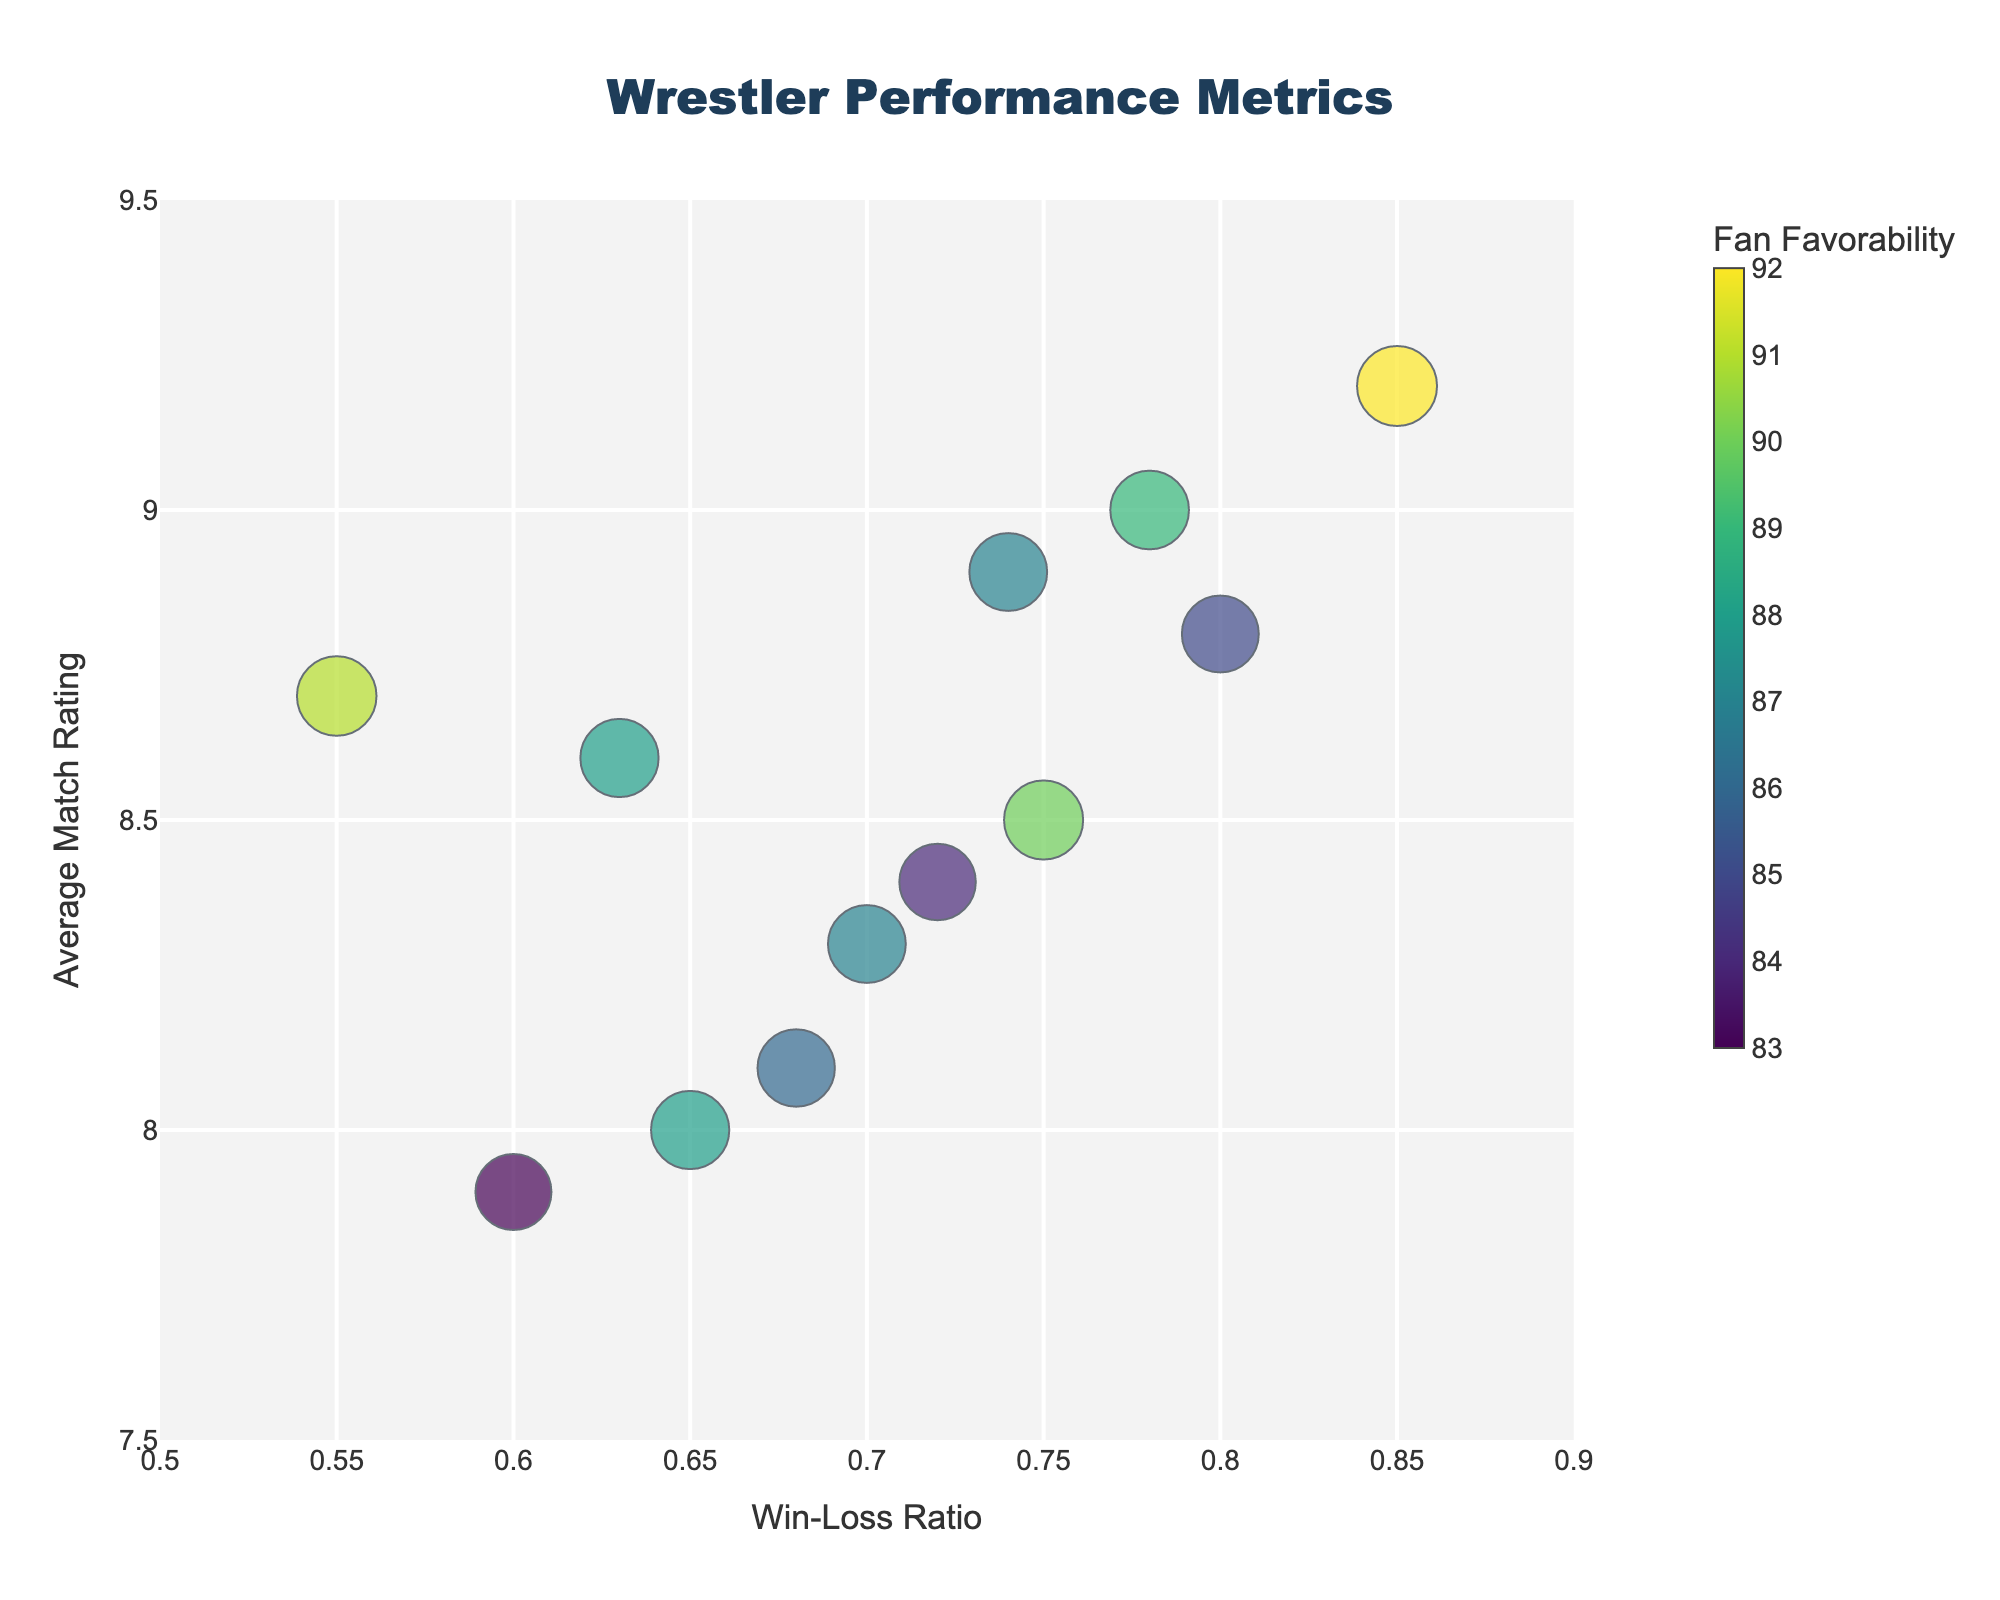what’s the title of the figure? The title of the figure is centralized at the top of the chart and often appears in a large font size to grab attention. In this case, the title is written in Arial Black font.
Answer: Wrestler Performance Metrics How many wrestlers have a Win-Loss Ratio above 0.75? Each wrestler's Win-Loss Ratio can be identified on the x-axis. Wrestlers above the 0.75 mark are John Cena, Roman Reigns, Kenny Omega, Kazuchika Okada, and AJ Styles.
Answer: 5 Which wrestler has the highest Average Match Rating? The highest Average Match Rating can be identified on the y-axis. The data point with the highest y-value is Kenny Omega with a rating of 9.2.
Answer: Kenny Omega Who has a higher Win-Loss Ratio, Becky Lynch or Roman Reigns? To compare their Win-Loss Ratios, we check their positions on the x-axis. Roman Reigns’ data point is further right than Becky Lynch’s, indicating a higher ratio.
Answer: Roman Reigns What is the range of Fan Favorability in the chart? The Fan Favorability is shown by the bubble size and the color scale. The minimum and maximum values can be identified through the colorbar legend. The range spans from Chris Jericho at 83 to Kenny Omega at 92.
Answer: 83 to 92 Which two wrestlers have similar Average Match Ratings but differ significantly in Win-Loss Ratio? The two wrestlers with similar Average Match Ratings can be found by looking for points close in the y-axis. Becky Lynch and Sasha Banks both have similar ratings around 8.0-8.3 but differ in their Win-Loss Ratios (0.70 for Becky Lynch and 0.65 for Sasha Banks).
Answer: Becky Lynch and Sasha Banks What is the Fan Favorability for The Undertaker? The Fan Favorability is shown by the bubble size and color. The Undertaker's data can be identified by his name in the hover text, and his Fan Favorability is 91 as indicated.
Answer: 91 Which wrestler has the second highest Average Match Rating? By checking the positions on the y-axis for the second highest point, we find that Kazuchika Okada has the second highest Average Match Rating of 9.0.
Answer: Kazuchika Okada How many wrestlers have an Average Match Rating below 8.0? Looking at the y-axis, we see that only Chris Jericho has an Average Match Rating below 8.0.
Answer: 1 Compare the Fan Favorability of AJ Styles and Becky Lynch. Who is higher and by how much? By examining the bubble sizes and hover text, AJ Styles has a Fan Favorability of 87, while Becky Lynch also has 87. They have the same Fan Favorability, so the difference is 0.
Answer: The same, 0 